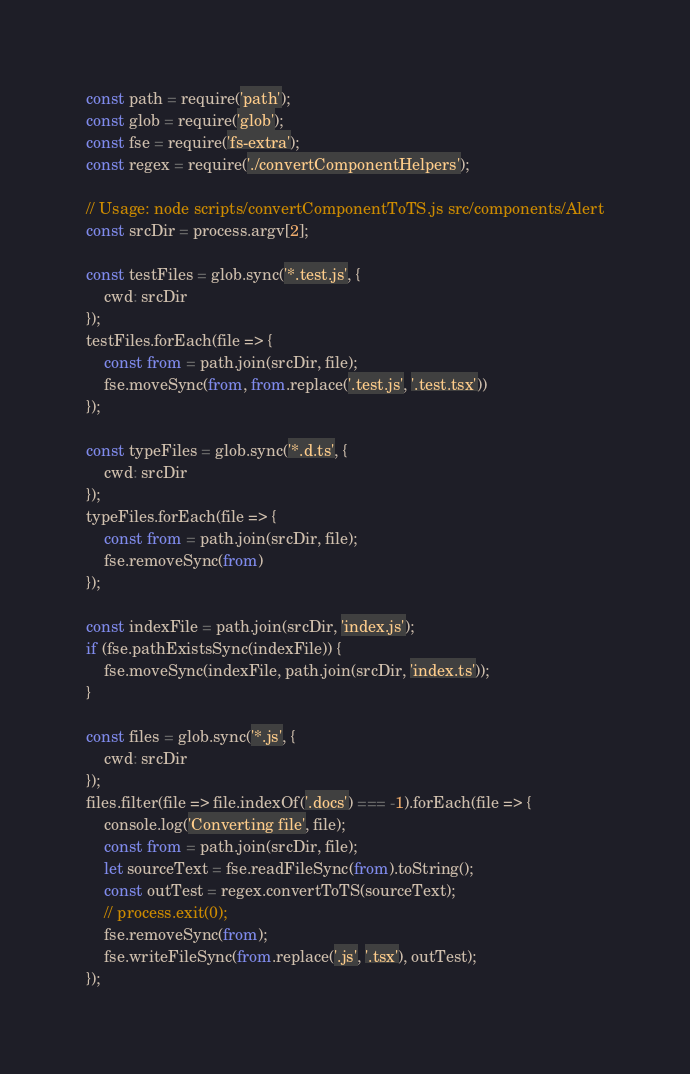Convert code to text. <code><loc_0><loc_0><loc_500><loc_500><_JavaScript_>const path = require('path');
const glob = require('glob');
const fse = require('fs-extra');
const regex = require('./convertComponentHelpers');

// Usage: node scripts/convertComponentToTS.js src/components/Alert
const srcDir = process.argv[2];

const testFiles = glob.sync('*.test.js', {
    cwd: srcDir
});
testFiles.forEach(file => {
    const from = path.join(srcDir, file);
    fse.moveSync(from, from.replace('.test.js', '.test.tsx'))
});

const typeFiles = glob.sync('*.d.ts', {
    cwd: srcDir
});
typeFiles.forEach(file => {
    const from = path.join(srcDir, file);
    fse.removeSync(from)
});

const indexFile = path.join(srcDir, 'index.js');
if (fse.pathExistsSync(indexFile)) {
    fse.moveSync(indexFile, path.join(srcDir, 'index.ts'));
}

const files = glob.sync('*.js', {
    cwd: srcDir
});
files.filter(file => file.indexOf('.docs') === -1).forEach(file => {
    console.log('Converting file', file);
    const from = path.join(srcDir, file);
    let sourceText = fse.readFileSync(from).toString();
    const outTest = regex.convertToTS(sourceText);
    // process.exit(0);
    fse.removeSync(from);
    fse.writeFileSync(from.replace('.js', '.tsx'), outTest);
});
</code> 